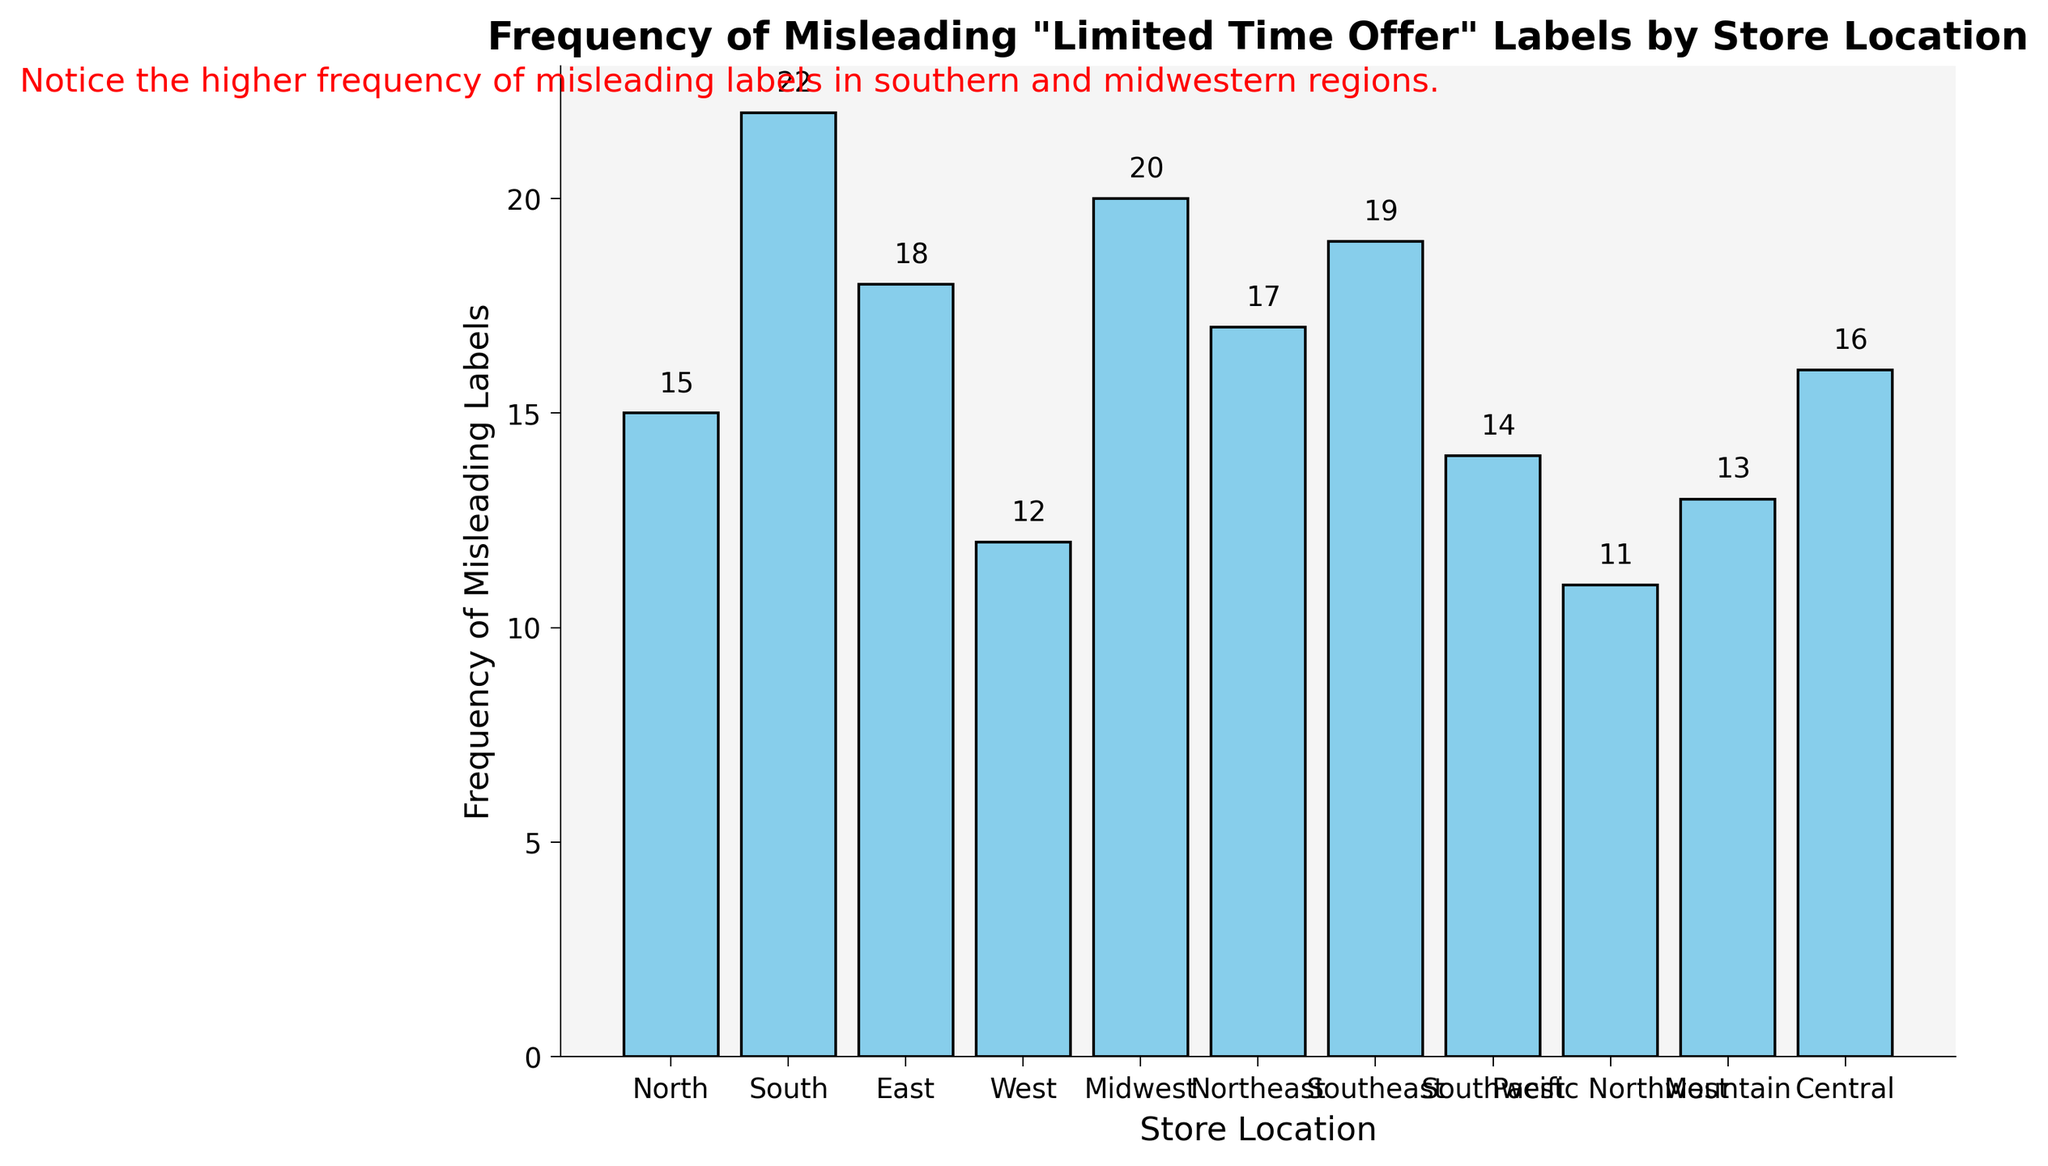Which store location has the highest frequency of misleading labels? The bar for the South store location is the tallest, indicating the highest frequency among all store locations.
Answer: South Which store location has the lowest frequency of misleading labels? The bar for the Pacific Northwest store location is the shortest, indicating the lowest frequency among all store locations.
Answer: Pacific Northwest What is the total frequency of misleading labels for the South and Midwest regions? The frequencies for South and Midwest are 22 and 20, respectively. Sum these values: 22 + 20 = 42
Answer: 42 How much greater is the frequency of misleading labels in the Southeast compared to the Southwest? Southeast has a frequency of 19 and Southwest has 14. Subtract the smaller value from the larger one: 19 - 14 = 5
Answer: 5 What is the average frequency of misleading labels across all store locations? Add all frequencies: 15 + 22 + 18 + 12 + 20 + 17 + 19 + 14 + 11 + 13 + 16 = 177. There are 11 locations, so average is 177/11 = 16.09 (approximately 16)
Answer: 16 Which store locations have a frequency of misleading labels above 18? South (22), Midwest (20), and Southeast (19) all have frequencies above 18.
Answer: South, Midwest, Southeast Is the frequency of misleading labels for the Mountain region higher than the Central region? The Mountain region has a frequency of 13, and the Central region has 16. Since 13 is less than 16, the answer is no.
Answer: No Compared to the East region, how many fewer misleading labels does the West region have? East has a frequency of 18, and West has 12. Subtract West's frequency from East's to get the difference: 18 - 12 = 6
Answer: 6 What trend is highlighted by the text annotation on the plot? The annotation states there is a higher frequency of misleading labels in the southern and midwestern regions, indicating a regional trend.
Answer: Higher frequency in southern and midwestern regions 